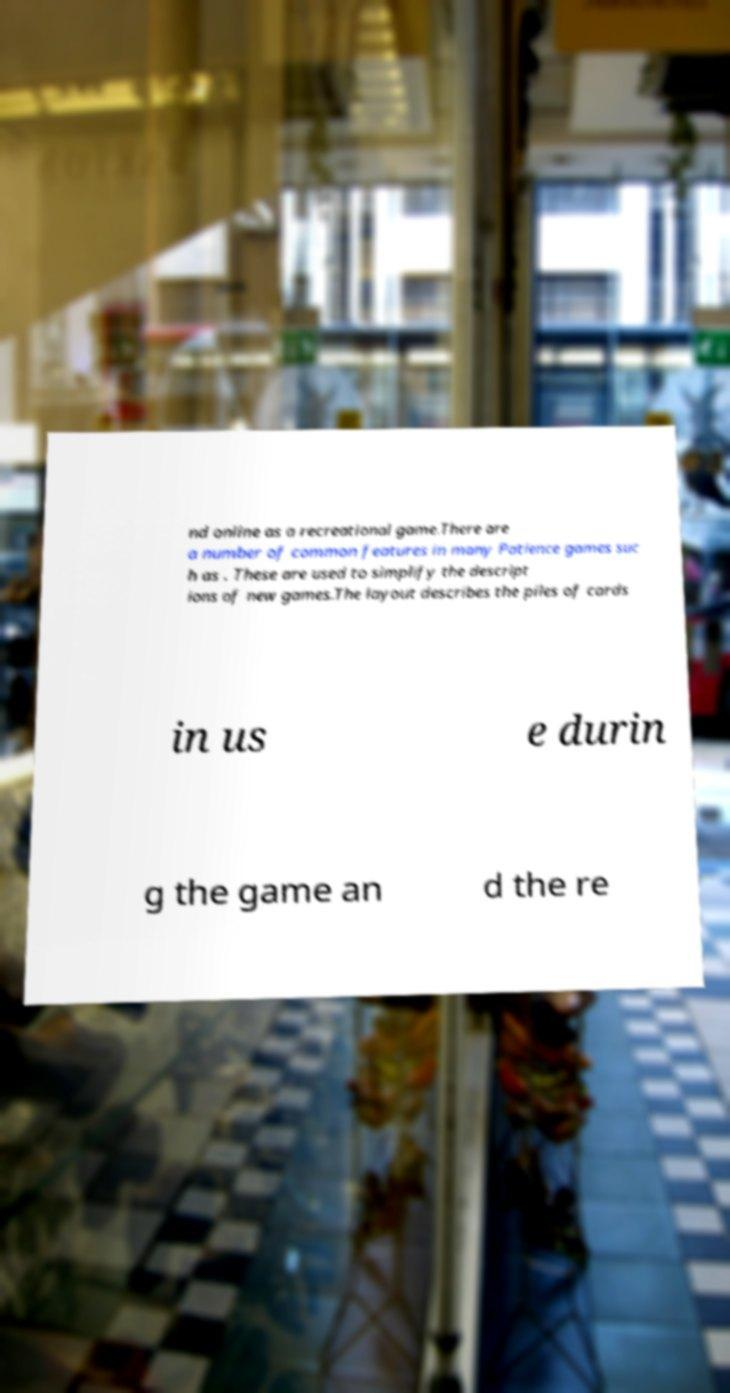I need the written content from this picture converted into text. Can you do that? nd online as a recreational game.There are a number of common features in many Patience games suc h as . These are used to simplify the descript ions of new games.The layout describes the piles of cards in us e durin g the game an d the re 